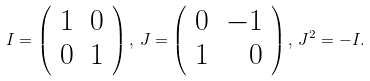Convert formula to latex. <formula><loc_0><loc_0><loc_500><loc_500>I = \left ( \begin{array} { r r } 1 & 0 \\ 0 & 1 \end{array} \right ) , \, J = \left ( \begin{array} { r r } 0 & - 1 \\ 1 & 0 \end{array} \right ) , \, J ^ { 2 } = - I .</formula> 